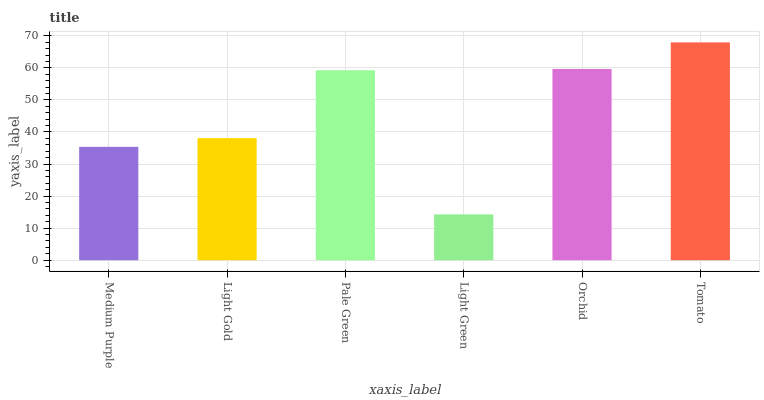Is Light Green the minimum?
Answer yes or no. Yes. Is Tomato the maximum?
Answer yes or no. Yes. Is Light Gold the minimum?
Answer yes or no. No. Is Light Gold the maximum?
Answer yes or no. No. Is Light Gold greater than Medium Purple?
Answer yes or no. Yes. Is Medium Purple less than Light Gold?
Answer yes or no. Yes. Is Medium Purple greater than Light Gold?
Answer yes or no. No. Is Light Gold less than Medium Purple?
Answer yes or no. No. Is Pale Green the high median?
Answer yes or no. Yes. Is Light Gold the low median?
Answer yes or no. Yes. Is Light Green the high median?
Answer yes or no. No. Is Pale Green the low median?
Answer yes or no. No. 